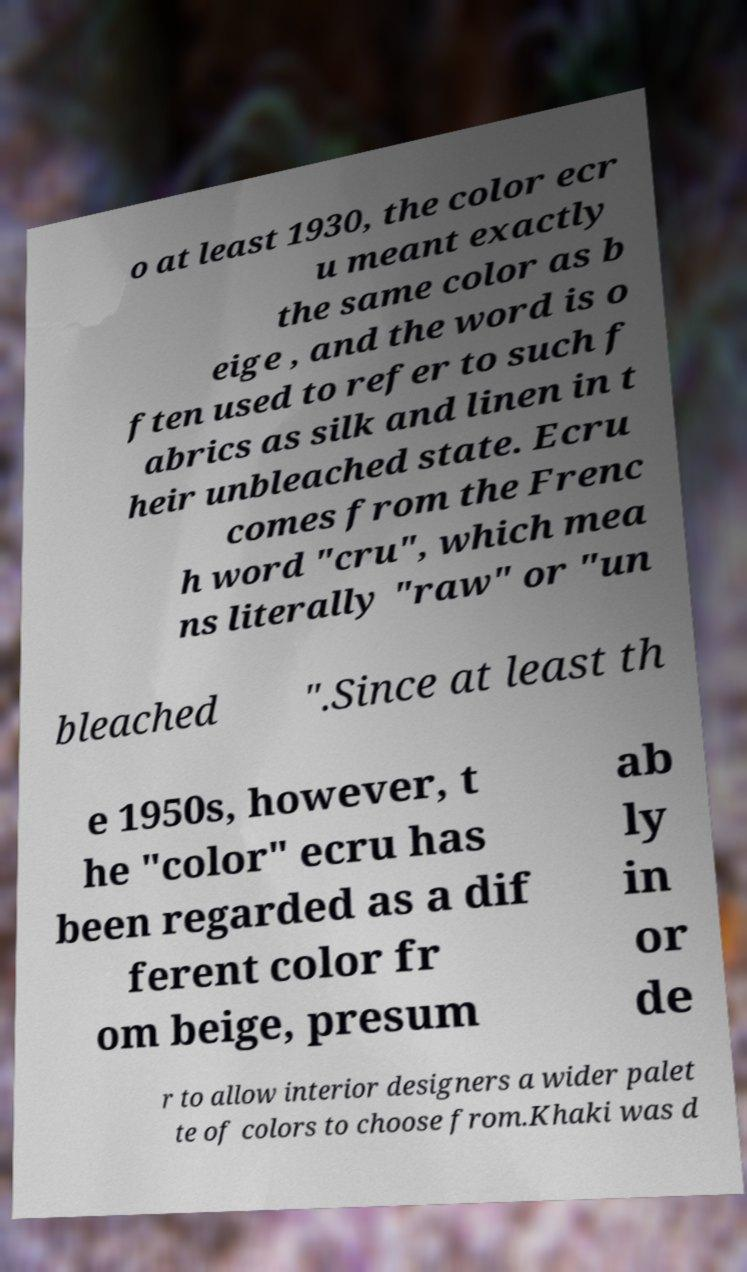I need the written content from this picture converted into text. Can you do that? o at least 1930, the color ecr u meant exactly the same color as b eige , and the word is o ften used to refer to such f abrics as silk and linen in t heir unbleached state. Ecru comes from the Frenc h word "cru", which mea ns literally "raw" or "un bleached ".Since at least th e 1950s, however, t he "color" ecru has been regarded as a dif ferent color fr om beige, presum ab ly in or de r to allow interior designers a wider palet te of colors to choose from.Khaki was d 